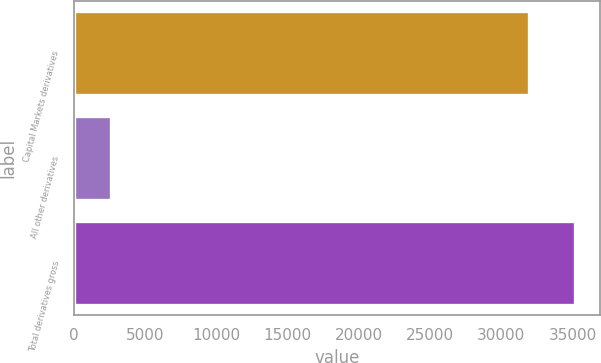Convert chart. <chart><loc_0><loc_0><loc_500><loc_500><bar_chart><fcel>Capital Markets derivatives<fcel>All other derivatives<fcel>Total derivatives gross<nl><fcel>31951<fcel>2554<fcel>35146.1<nl></chart> 